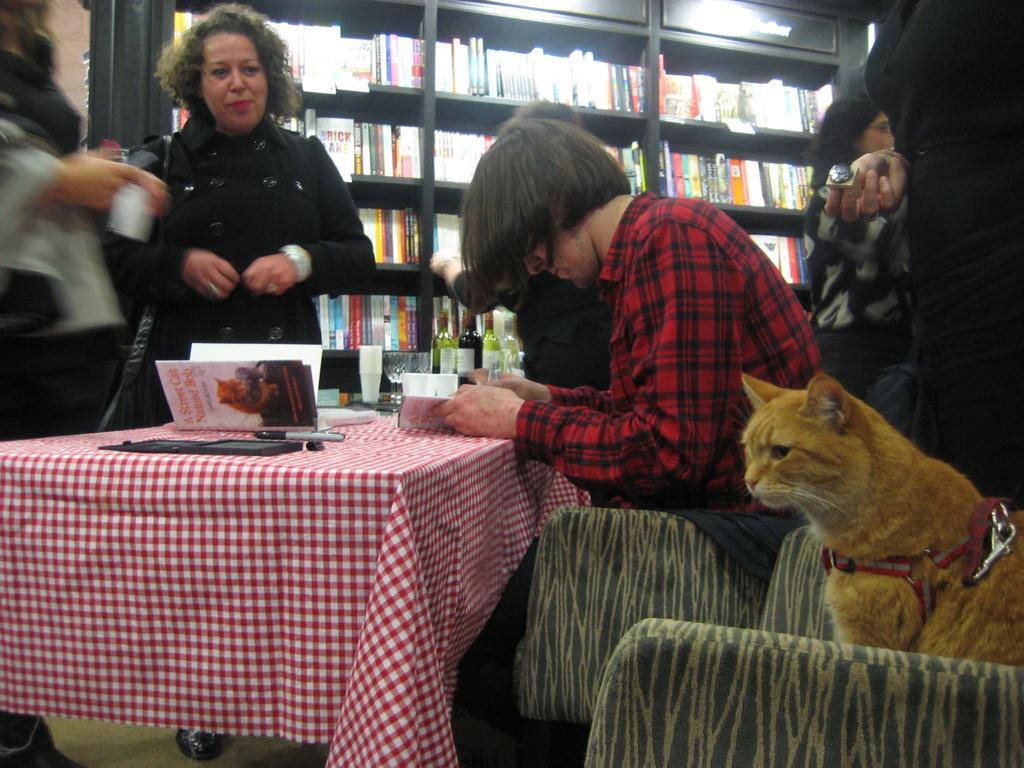Describe this image in one or two sentences. In this picture there is a man sitting in the chair and there is a table, on this table there are few books. A woman is standing beside the table, she is a wearing a black dress. On the left there is a woman standing holding something in her hand. On the right there are two people standing. On the right there is a cat sitting in the chair. In the background there is a book shelf containing many books and there are few wine bottles. 